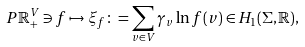Convert formula to latex. <formula><loc_0><loc_0><loc_500><loc_500>P \mathbb { R } _ { + } ^ { V } \ni f \mapsto \xi _ { f } \colon = \sum _ { v \in V } \gamma _ { v } \ln f ( v ) \in H _ { 1 } ( \Sigma , \mathbb { R } ) ,</formula> 